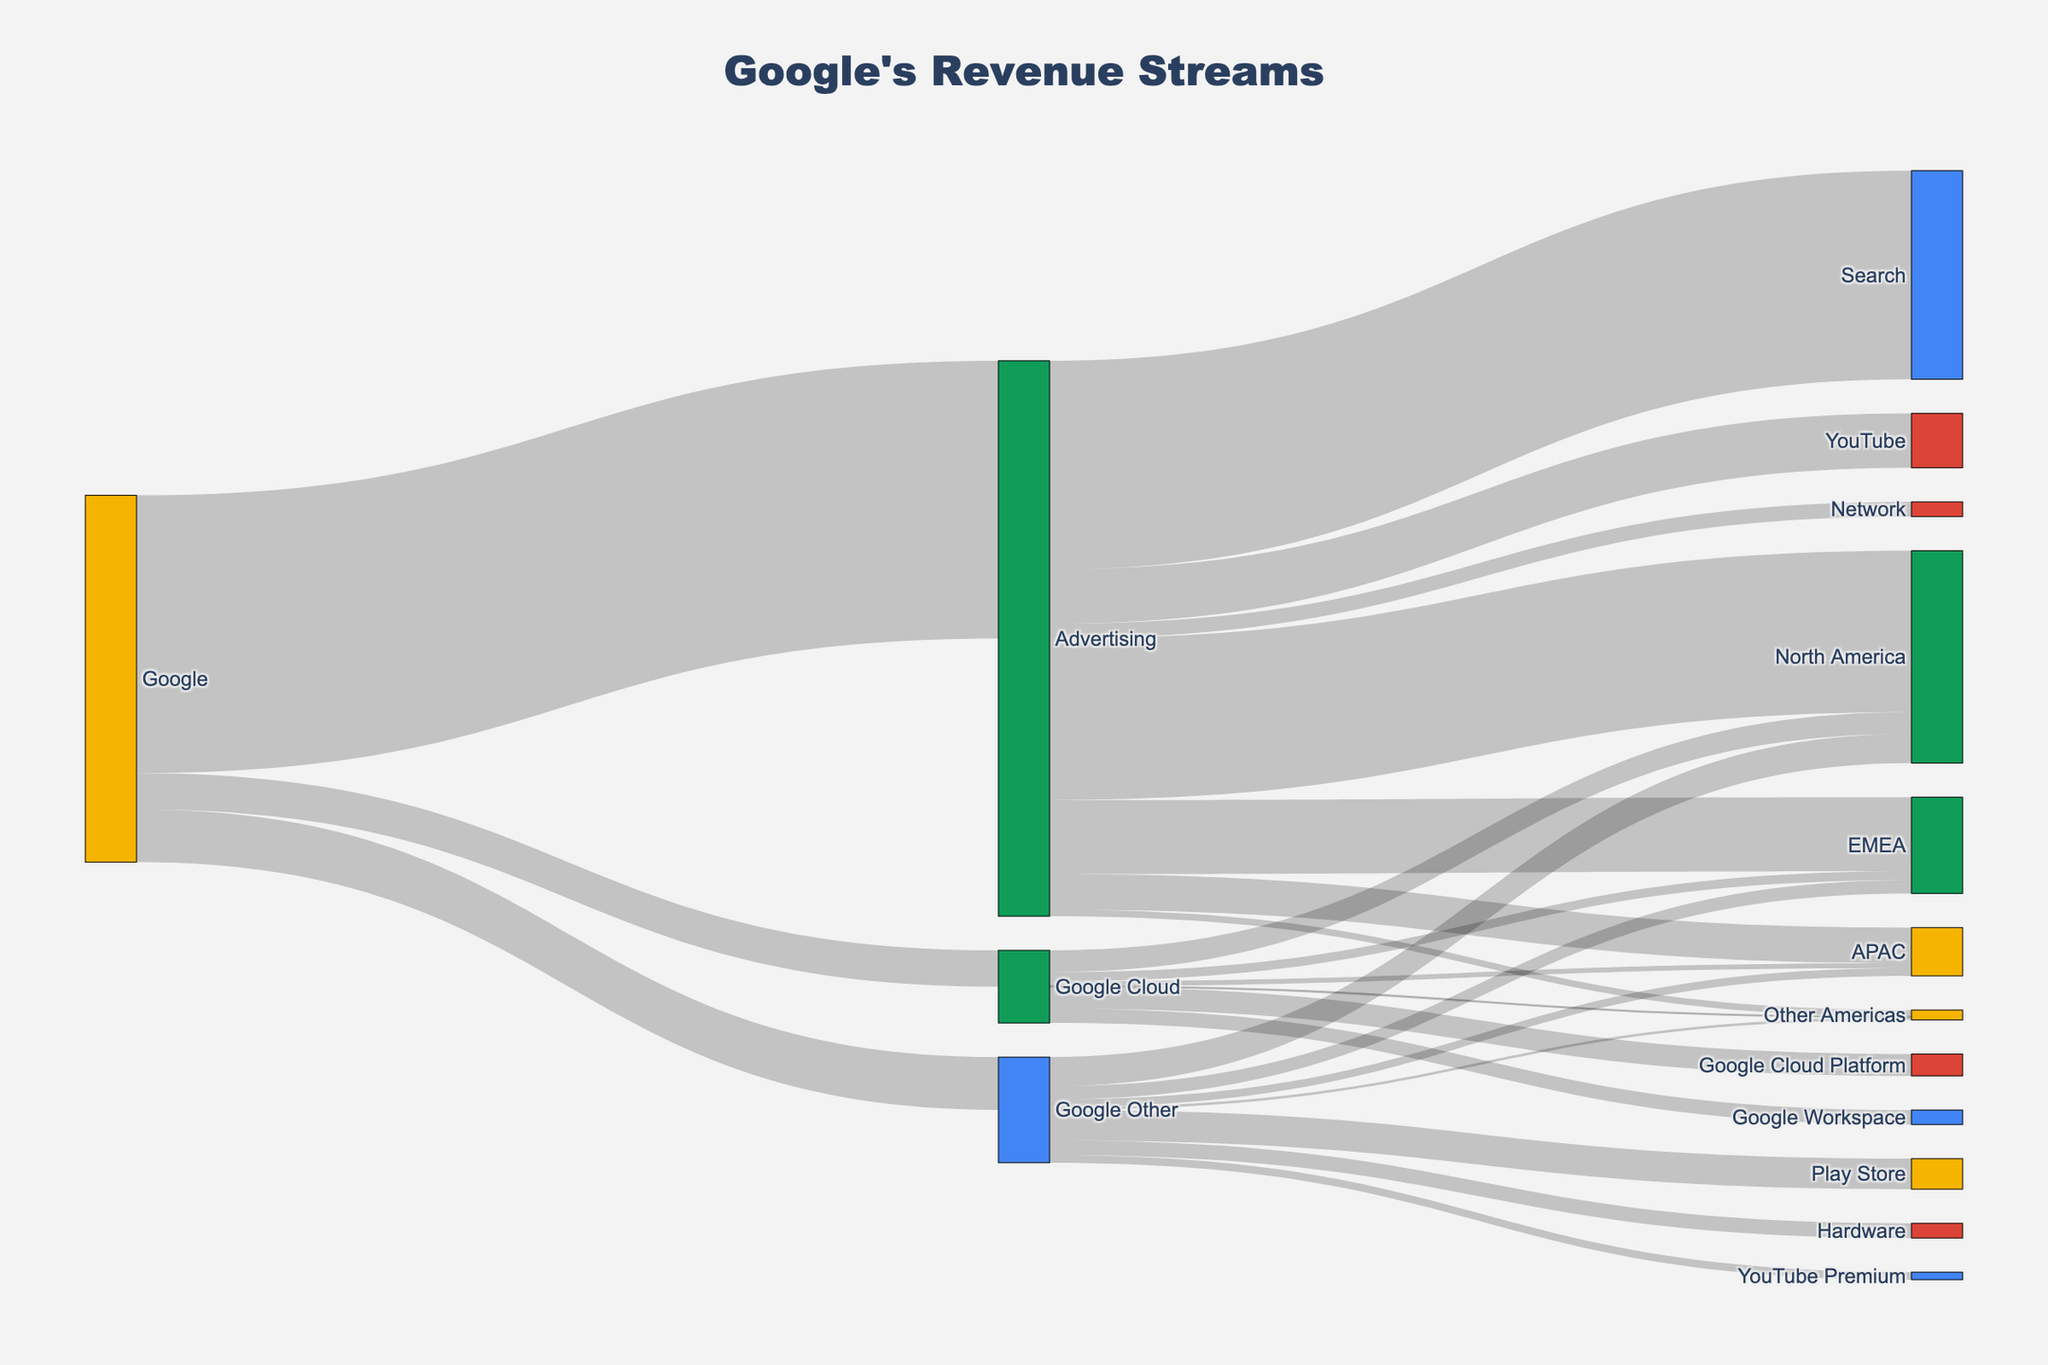What is the title of the Sankey Diagram? The title of the Sankey Diagram is typically positioned at the top center of the figure in a larger and bold font. From the code provided, the title is "Google's Revenue Streams."
Answer: Google's Revenue Streams Which product category generates the highest revenue for Google? By following the links from Google, the Advertising category shows the highest revenue at 147,461. This value is the largest among all categories connected to Google.
Answer: Advertising How much revenue does the YouTube component of Advertising generate? The link going from Advertising to YouTube shows a revenue value. From the provided data, YouTube under Advertising generates 28,845.
Answer: 28,845 What is the total revenue from the Google Other category? The total revenue in the Google Other category is the sum of revenues from the Play Store, Hardware, and YouTube Premium, which are 16218 + 7814 + 4000. Therefore, 16218 + 7814 + 4000 = 28032.
Answer: 28032 Compare the revenue generated by Google Cloud Platform and Google Workspace within the Google Cloud category. Which one generates more? By looking at the links under the Google Cloud category, Google Cloud Platform generates 11587, and Google Workspace generates 7694. Clearly, 11587 is greater than 7694.
Answer: Google Cloud Platform What is the total revenue generated in North America from all categories combined? The contributions to North America come from Advertising, Google Cloud, and Google Other. The values are 85732, 11569, and 15418 respectively. Adding them together: 85732 + 11569 + 15418 = 112719.
Answer: 112719 Which geographical region generates the least revenue for Google Cloud? There are four geographical regions receiving revenue from Google Cloud. The values are North America (11569), EMEA (4820), APAC (2506), and Other Americas (386). The smallest value is 386 from Other Americas.
Answer: Other Americas Within the Advertising category, how does the revenue compare between North America and APAC? Under the Advertising category, North America and APAC receive 85732 and 18963 respectively. North America's value is significantly higher compared to APAC's value.
Answer: North America has higher revenue than APAC What is the combined revenue from Advertising and Google Cloud categories? The revenues for Advertising and Google Cloud are 147461 and 19281 respectively. Adding these gives: 147461 + 19281 = 166742.
Answer: 166742 Which category under Google Other contributes the least revenue? The three components under Google Other are Play Store (16218), Hardware (7814), and YouTube Premium (4000). YouTube Premium has the smallest value.
Answer: YouTube Premium 